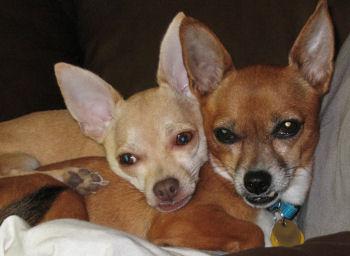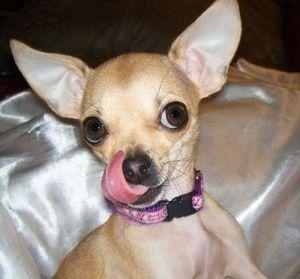The first image is the image on the left, the second image is the image on the right. Given the left and right images, does the statement "An image shows two tan dogs with heads side-by-side and erect ears, and one is wearing a bright blue collar." hold true? Answer yes or no. Yes. The first image is the image on the left, the second image is the image on the right. Evaluate the accuracy of this statement regarding the images: "One of the dogs is wearing a pink collar.". Is it true? Answer yes or no. Yes. 